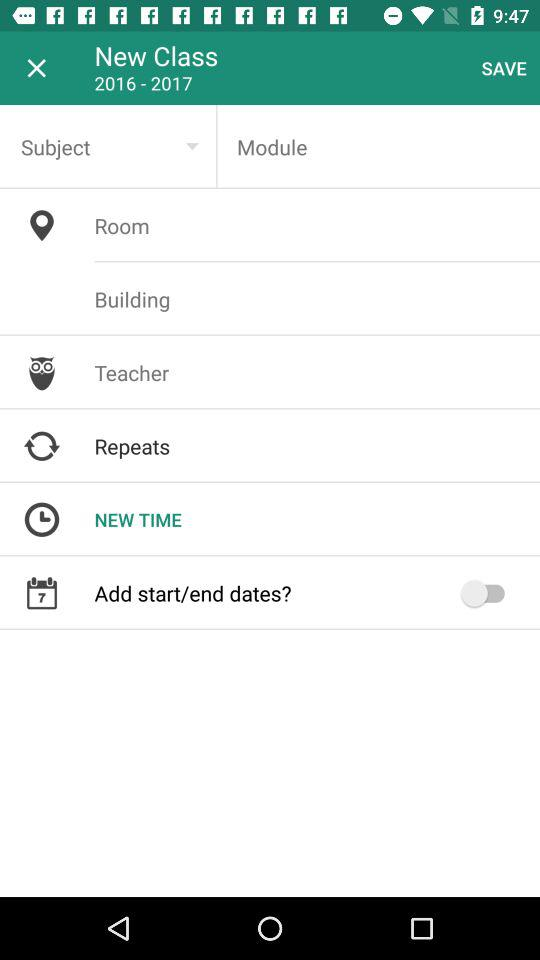Which year range is selected? The selected year range is from 2016 to 2017. 